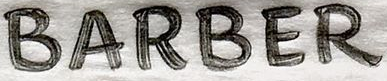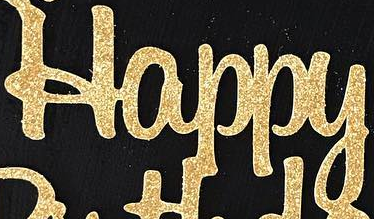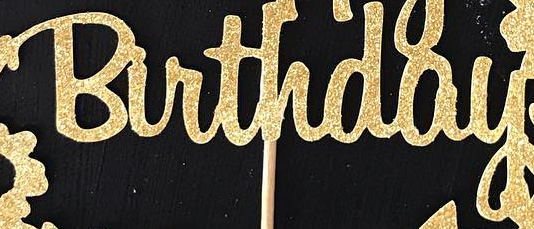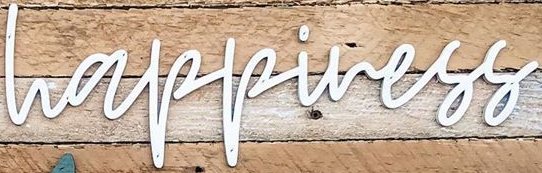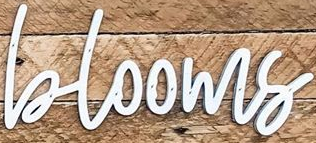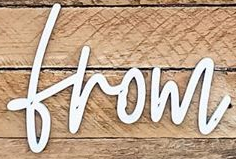Read the text content from these images in order, separated by a semicolon. BARBER; Happy; Birthday; happiness; blooms; from 